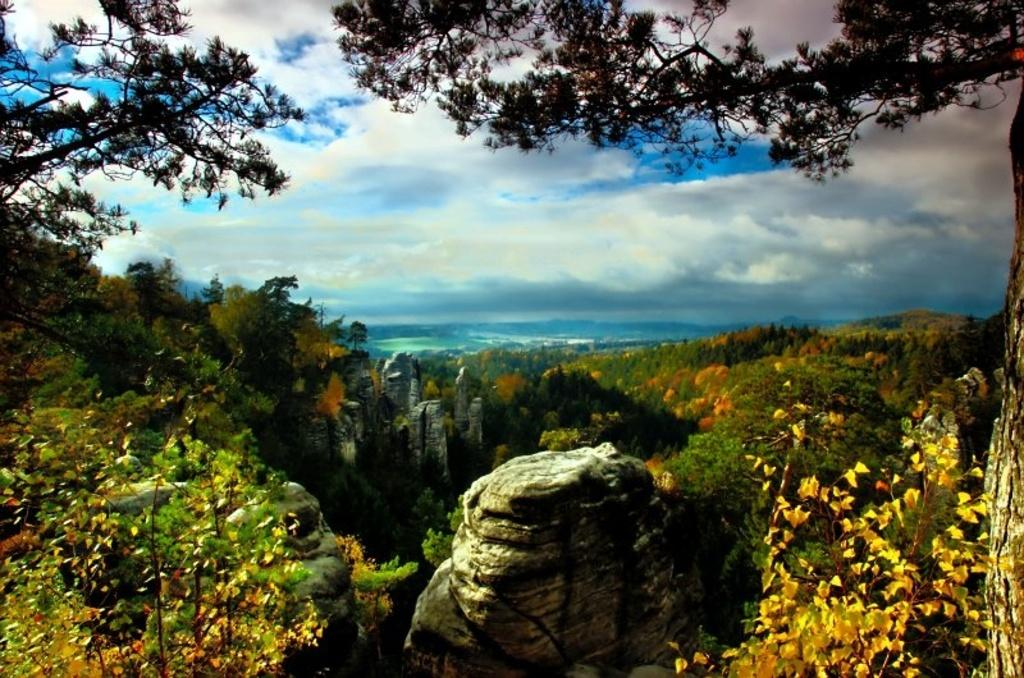What type of vegetation can be seen in the image? There are trees in the image. What geographical features are present in the image? There are hills in the image. What is visible in the background of the image? The sky is visible in the background of the image. How many quince are growing on the trees in the image? There are no quince mentioned or visible in the image; it only features trees. What type of wound can be seen on the hill in the image? There is no wound present on the hill or any other part of the image. 